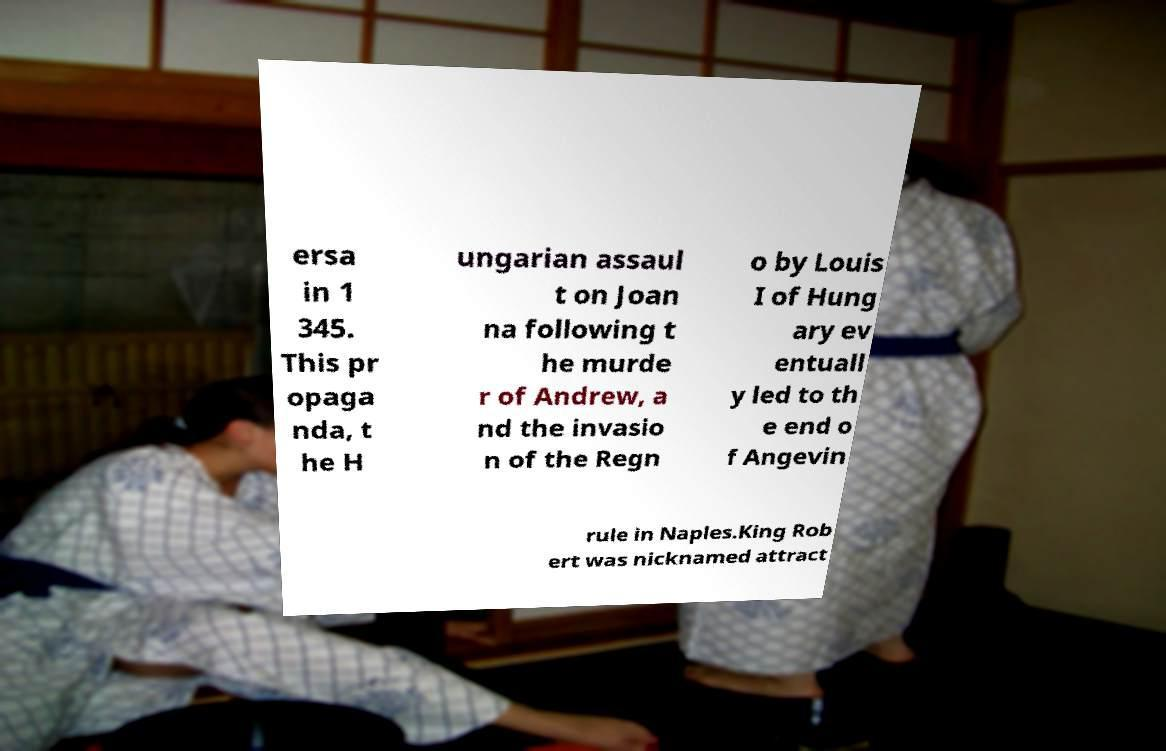For documentation purposes, I need the text within this image transcribed. Could you provide that? ersa in 1 345. This pr opaga nda, t he H ungarian assaul t on Joan na following t he murde r of Andrew, a nd the invasio n of the Regn o by Louis I of Hung ary ev entuall y led to th e end o f Angevin rule in Naples.King Rob ert was nicknamed attract 